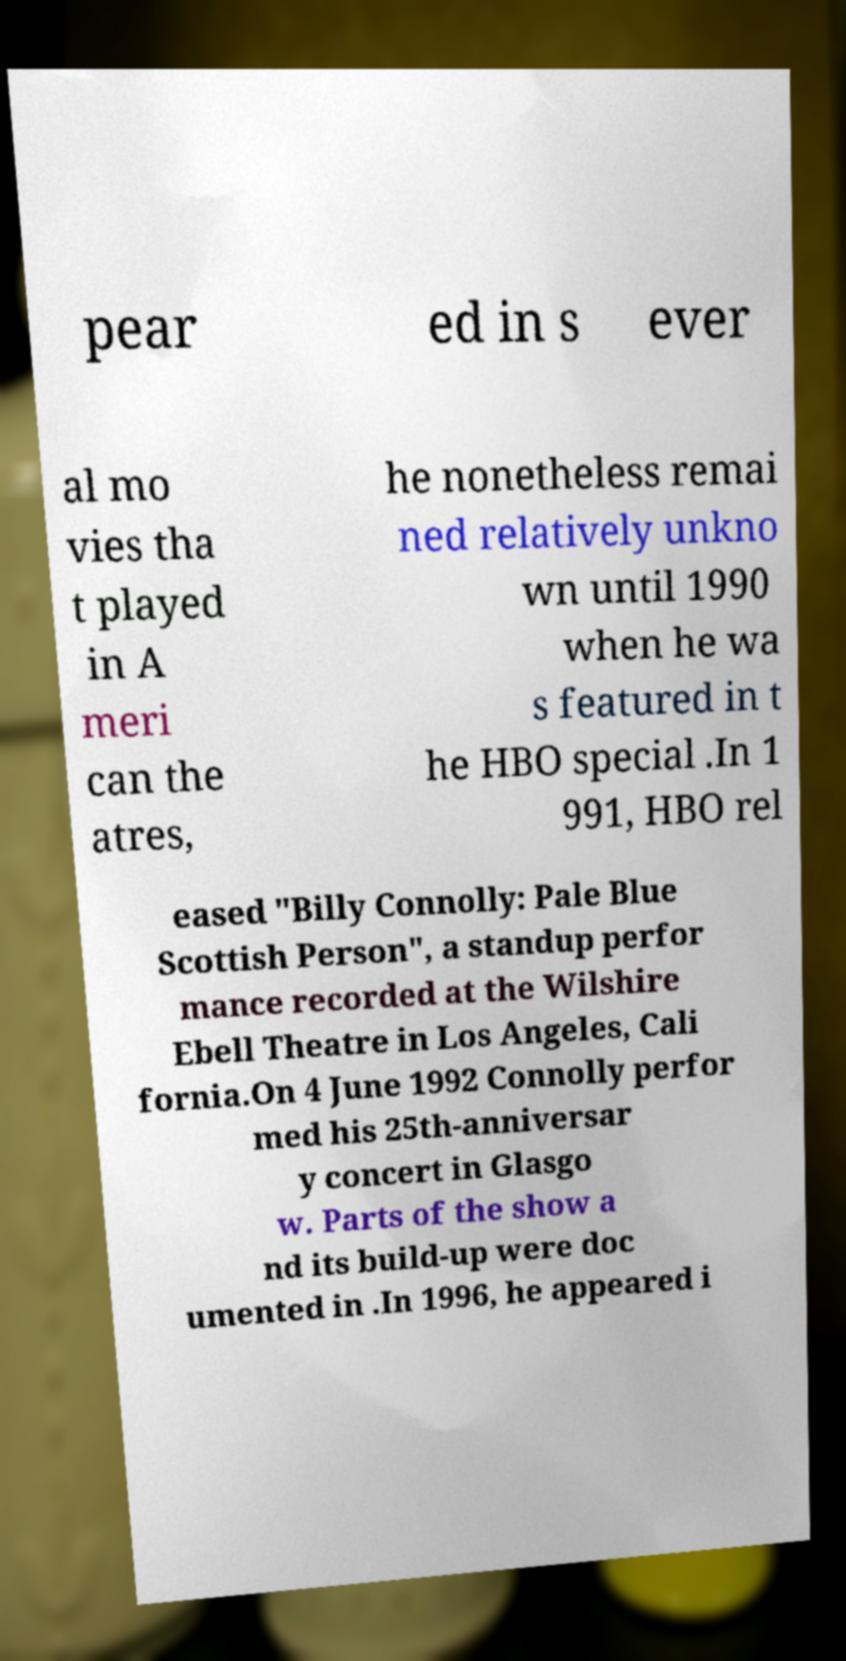What messages or text are displayed in this image? I need them in a readable, typed format. pear ed in s ever al mo vies tha t played in A meri can the atres, he nonetheless remai ned relatively unkno wn until 1990 when he wa s featured in t he HBO special .In 1 991, HBO rel eased "Billy Connolly: Pale Blue Scottish Person", a standup perfor mance recorded at the Wilshire Ebell Theatre in Los Angeles, Cali fornia.On 4 June 1992 Connolly perfor med his 25th-anniversar y concert in Glasgo w. Parts of the show a nd its build-up were doc umented in .In 1996, he appeared i 